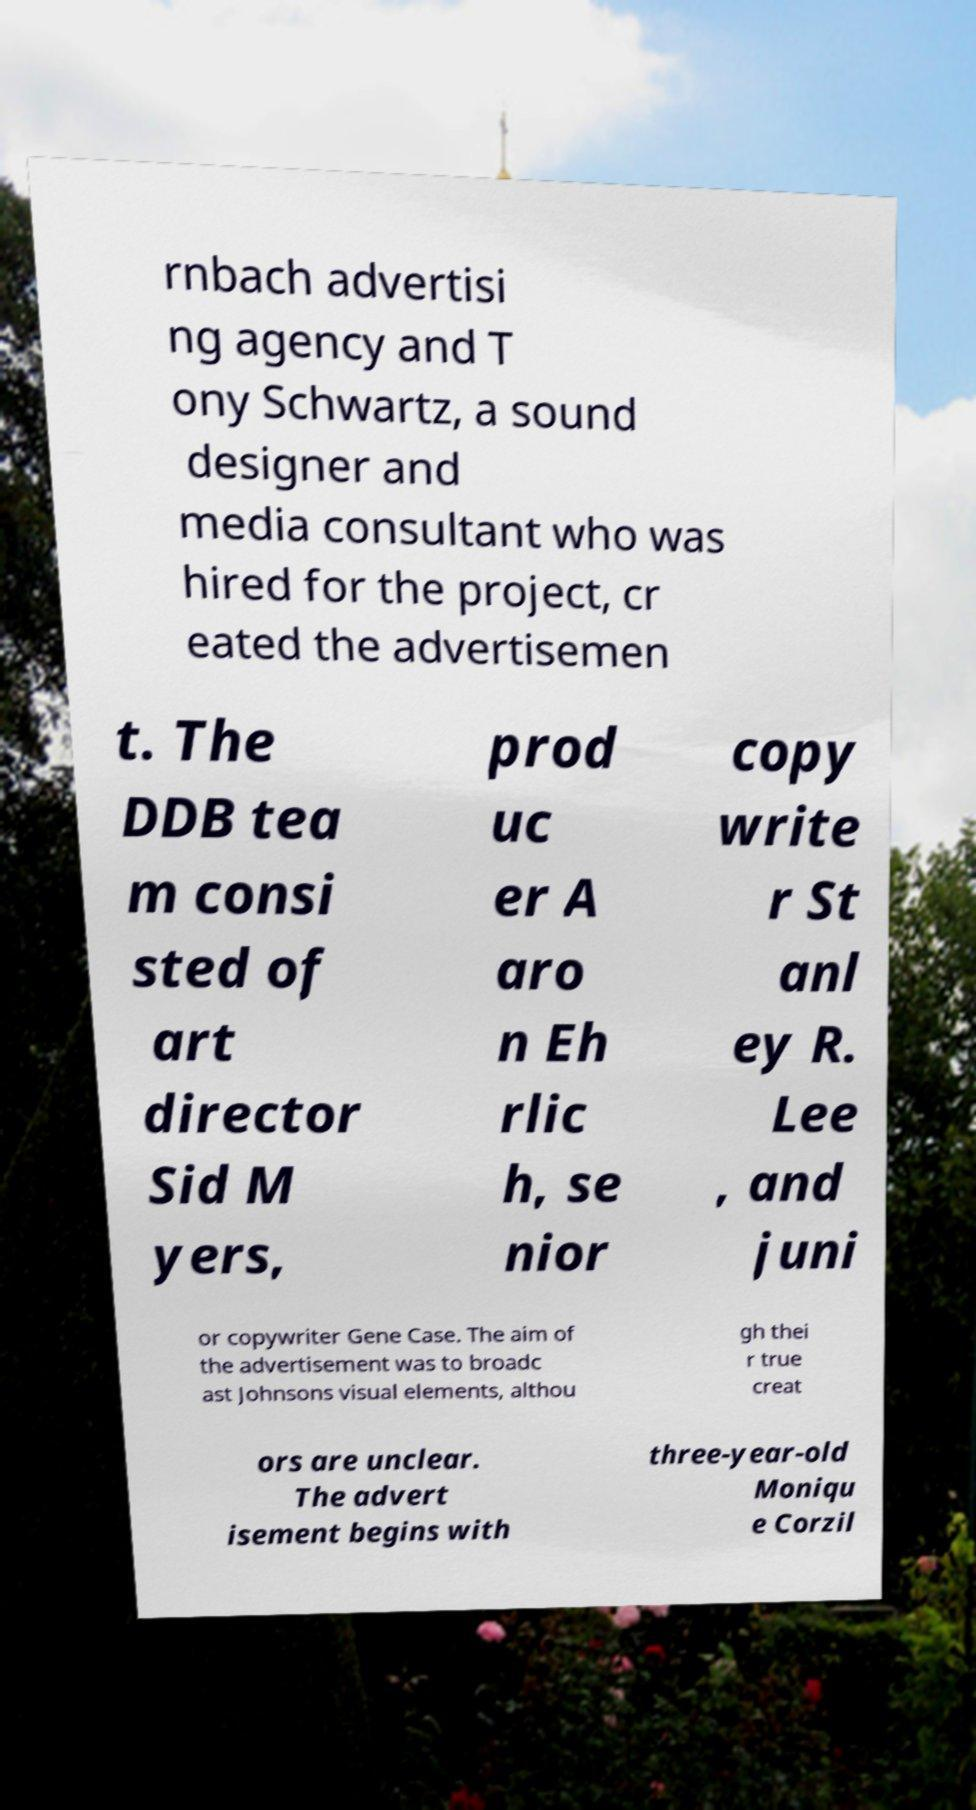Can you accurately transcribe the text from the provided image for me? rnbach advertisi ng agency and T ony Schwartz, a sound designer and media consultant who was hired for the project, cr eated the advertisemen t. The DDB tea m consi sted of art director Sid M yers, prod uc er A aro n Eh rlic h, se nior copy write r St anl ey R. Lee , and juni or copywriter Gene Case. The aim of the advertisement was to broadc ast Johnsons visual elements, althou gh thei r true creat ors are unclear. The advert isement begins with three-year-old Moniqu e Corzil 